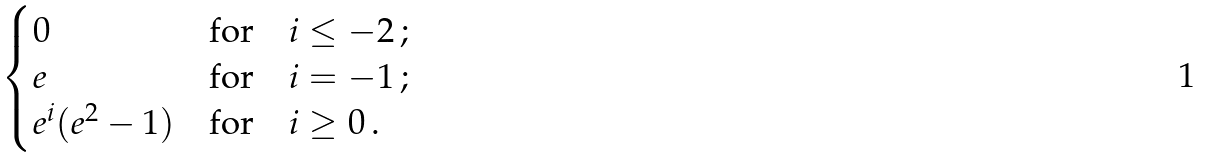Convert formula to latex. <formula><loc_0><loc_0><loc_500><loc_500>\begin{cases} 0 \quad & \text {for} \quad i \leq - 2 \, ; \\ e & \text {for} \quad i = - 1 \, ; \\ e ^ { i } ( e ^ { 2 } - 1 ) & \text {for} \quad i \geq 0 \, . \end{cases}</formula> 